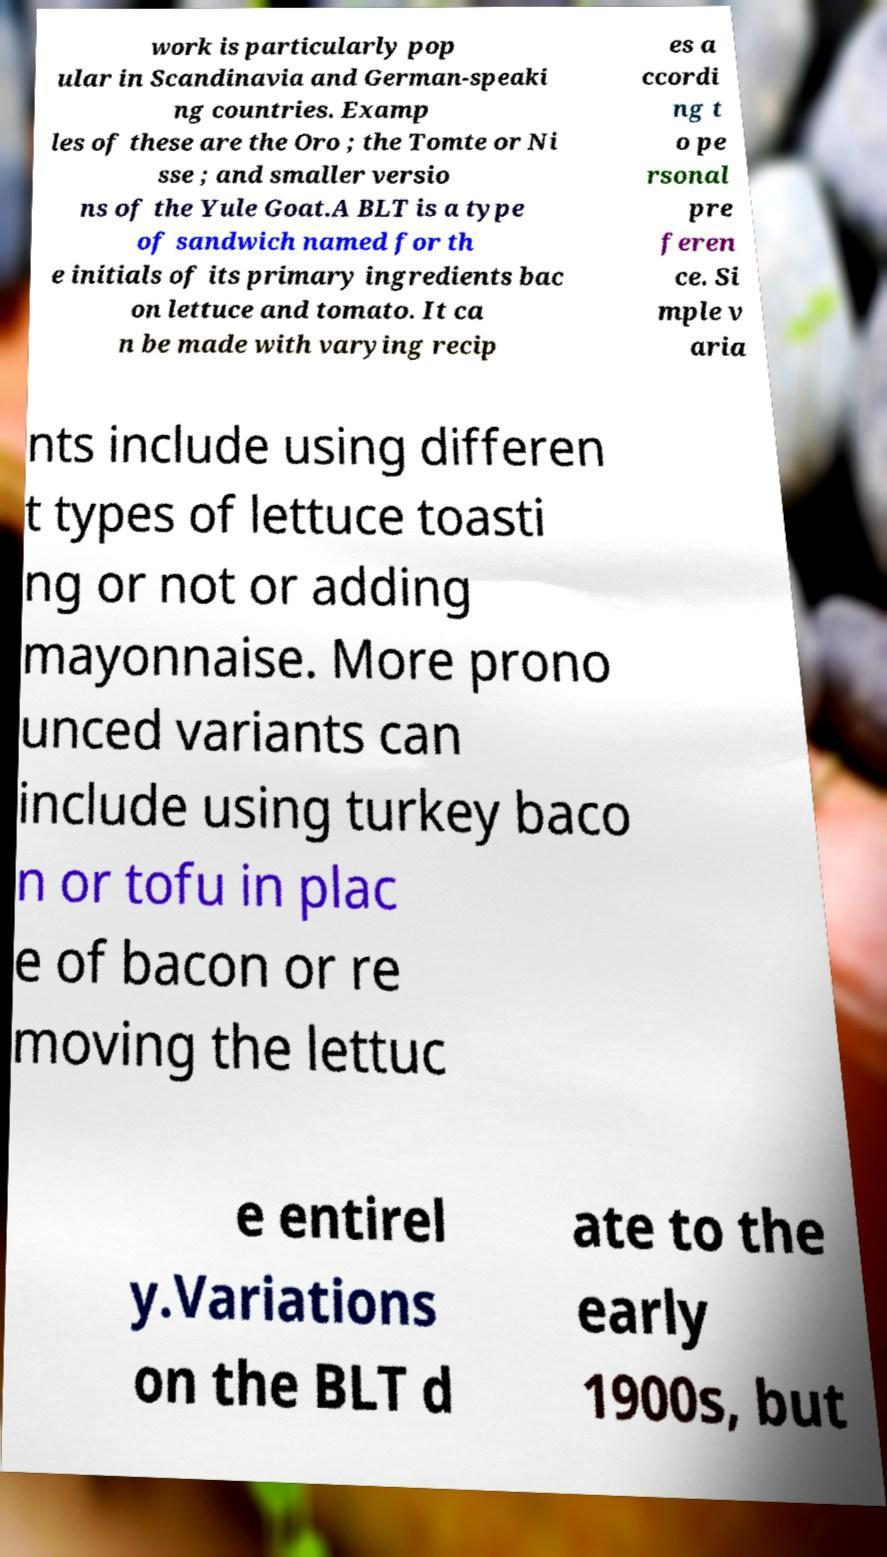Could you assist in decoding the text presented in this image and type it out clearly? work is particularly pop ular in Scandinavia and German-speaki ng countries. Examp les of these are the Oro ; the Tomte or Ni sse ; and smaller versio ns of the Yule Goat.A BLT is a type of sandwich named for th e initials of its primary ingredients bac on lettuce and tomato. It ca n be made with varying recip es a ccordi ng t o pe rsonal pre feren ce. Si mple v aria nts include using differen t types of lettuce toasti ng or not or adding mayonnaise. More prono unced variants can include using turkey baco n or tofu in plac e of bacon or re moving the lettuc e entirel y.Variations on the BLT d ate to the early 1900s, but 